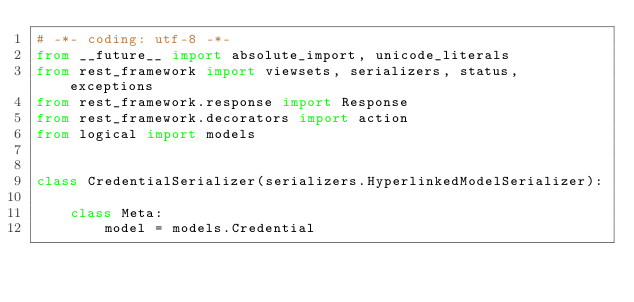Convert code to text. <code><loc_0><loc_0><loc_500><loc_500><_Python_># -*- coding: utf-8 -*-
from __future__ import absolute_import, unicode_literals
from rest_framework import viewsets, serializers, status, exceptions
from rest_framework.response import Response
from rest_framework.decorators import action
from logical import models


class CredentialSerializer(serializers.HyperlinkedModelSerializer):

    class Meta:
        model = models.Credential</code> 